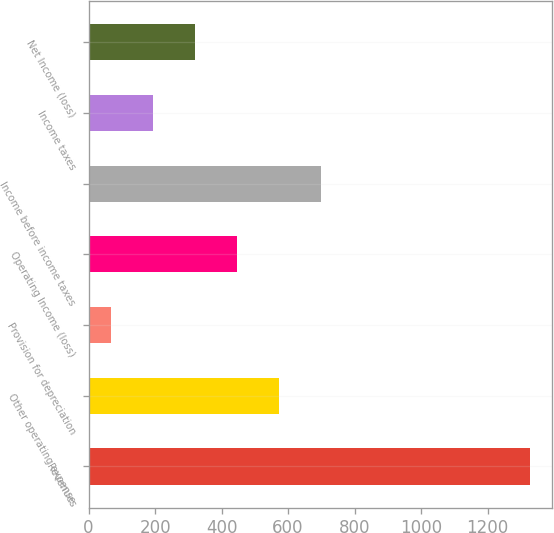Convert chart. <chart><loc_0><loc_0><loc_500><loc_500><bar_chart><fcel>Revenues<fcel>Other operating expense<fcel>Provision for depreciation<fcel>Operating Income (loss)<fcel>Income before income taxes<fcel>Income taxes<fcel>Net Income (loss)<nl><fcel>1327<fcel>571.6<fcel>68<fcel>445.7<fcel>697.5<fcel>193.9<fcel>319.8<nl></chart> 